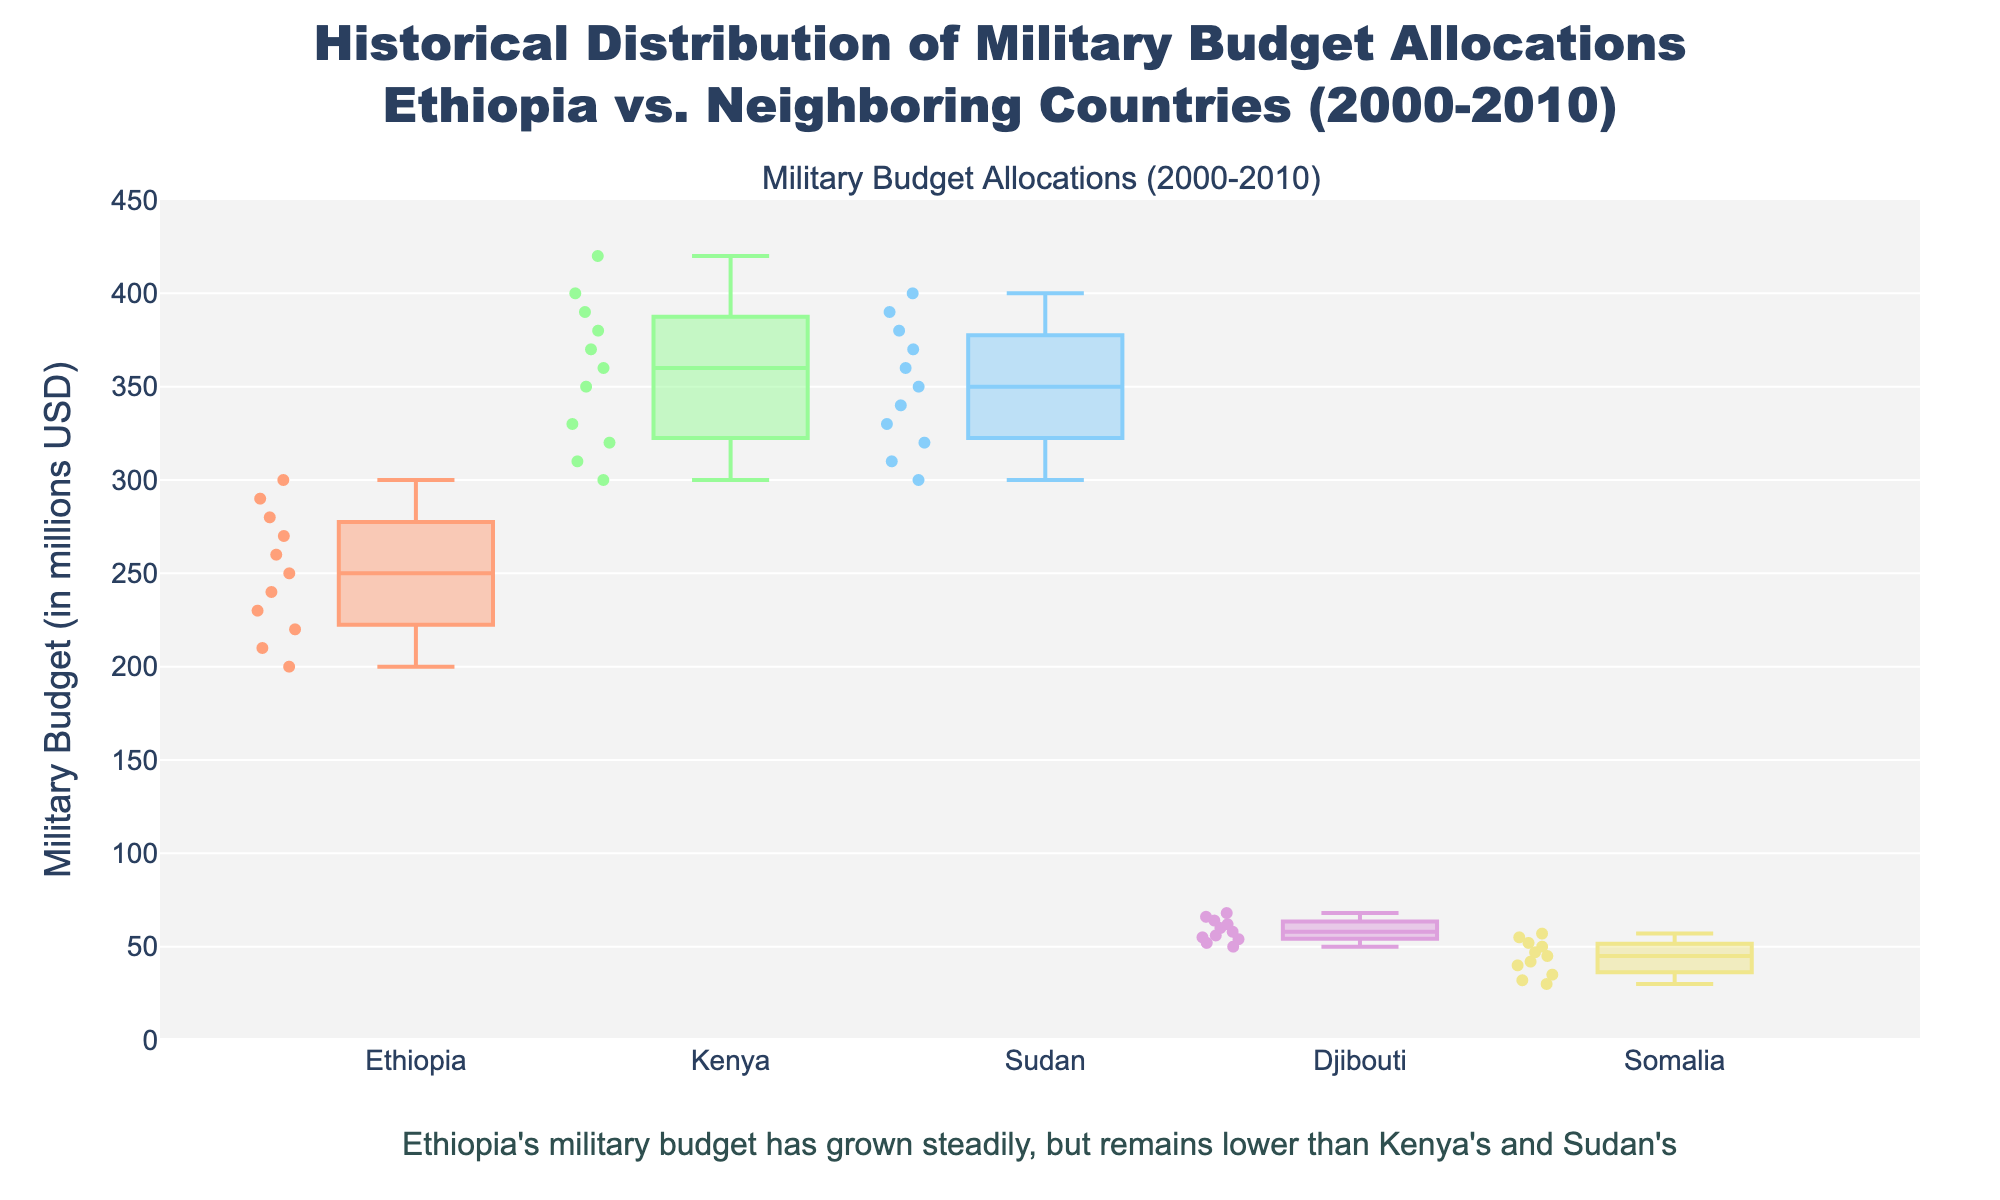What is the title of the figure? The title is typically located at the top of the figure. It reads, "Historical Distribution of Military Budget Allocations Ethiopia vs. Neighboring Countries (2000-2010)."
Answer: Historical Distribution of Military Budget Allocations Ethiopia vs. Neighboring Countries (2000-2010) Which country has the highest median military budget based on the box plots? The median is represented by the middle line in each box plot. By comparing these, Kenya's median line is the highest.
Answer: Kenya What is the color representing Sudan's military budget in the figure? Each country's box plot is colored differently. Sudan's military budget is represented by the third color in the legend, which is typically purple.
Answer: Purple How has Ethiopia's annual military budget trended from 2000 to 2010? Observing the scatter points within Ethiopia's box plot, it is evident that the annual military budget generally increases over the years from 2000 to 2010.
Answer: Increasing Which country has the widest range of military budget values over the years? The range is indicated by the distance between the top and bottom whiskers of the box plot. Kenya's box plot has the widest range.
Answer: Kenya How do the interquartile ranges of Ethiopia and Kenya's military budgets compare? The interquartile range (IQR) is the height of the box. Kenya's IQR is larger than Ethiopia's, indicating more variability in Kenya's military budget.
Answer: Kenya's IQR is larger Between Ethiopia and Sudan, which country’s military budget shows more consistent values? Consistency is represented by the narrowness of the box plot. Sudan's box plot is narrower than Ethiopia's, indicating more consistent values.
Answer: Sudan What does the annotation at the bottom of the figure state about Ethiopia's military budget? The annotation provides a specific insight into Ethiopia's budget trends. It states: "Ethiopia's military budget has grown steadily, but remains lower than Kenya's and Sudan's."
Answer: Ethiopia's military budget has grown steadily, but remains lower than Kenya's and Sudan's Which year shows the highest military budget for Djibouti and what is the amount? By looking at the highest scatter points within Djibouti's box plot, the year 2010 shows the highest budget at 68 million USD.
Answer: 2010, 68 million USD How do the military budgets of Somalia compare throughout the years? Somalia’s box plot and scatter points show relatively low and consistent budgets with slight increases over the years.
Answer: Low and consistent with slight increases 